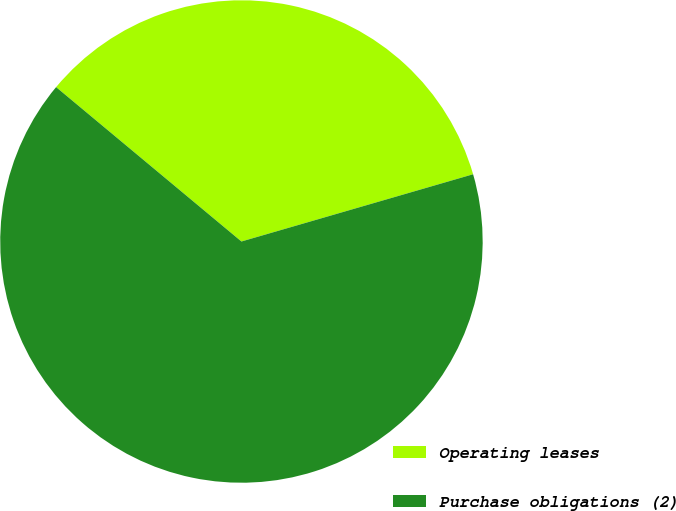Convert chart to OTSL. <chart><loc_0><loc_0><loc_500><loc_500><pie_chart><fcel>Operating leases<fcel>Purchase obligations (2)<nl><fcel>34.45%<fcel>65.55%<nl></chart> 